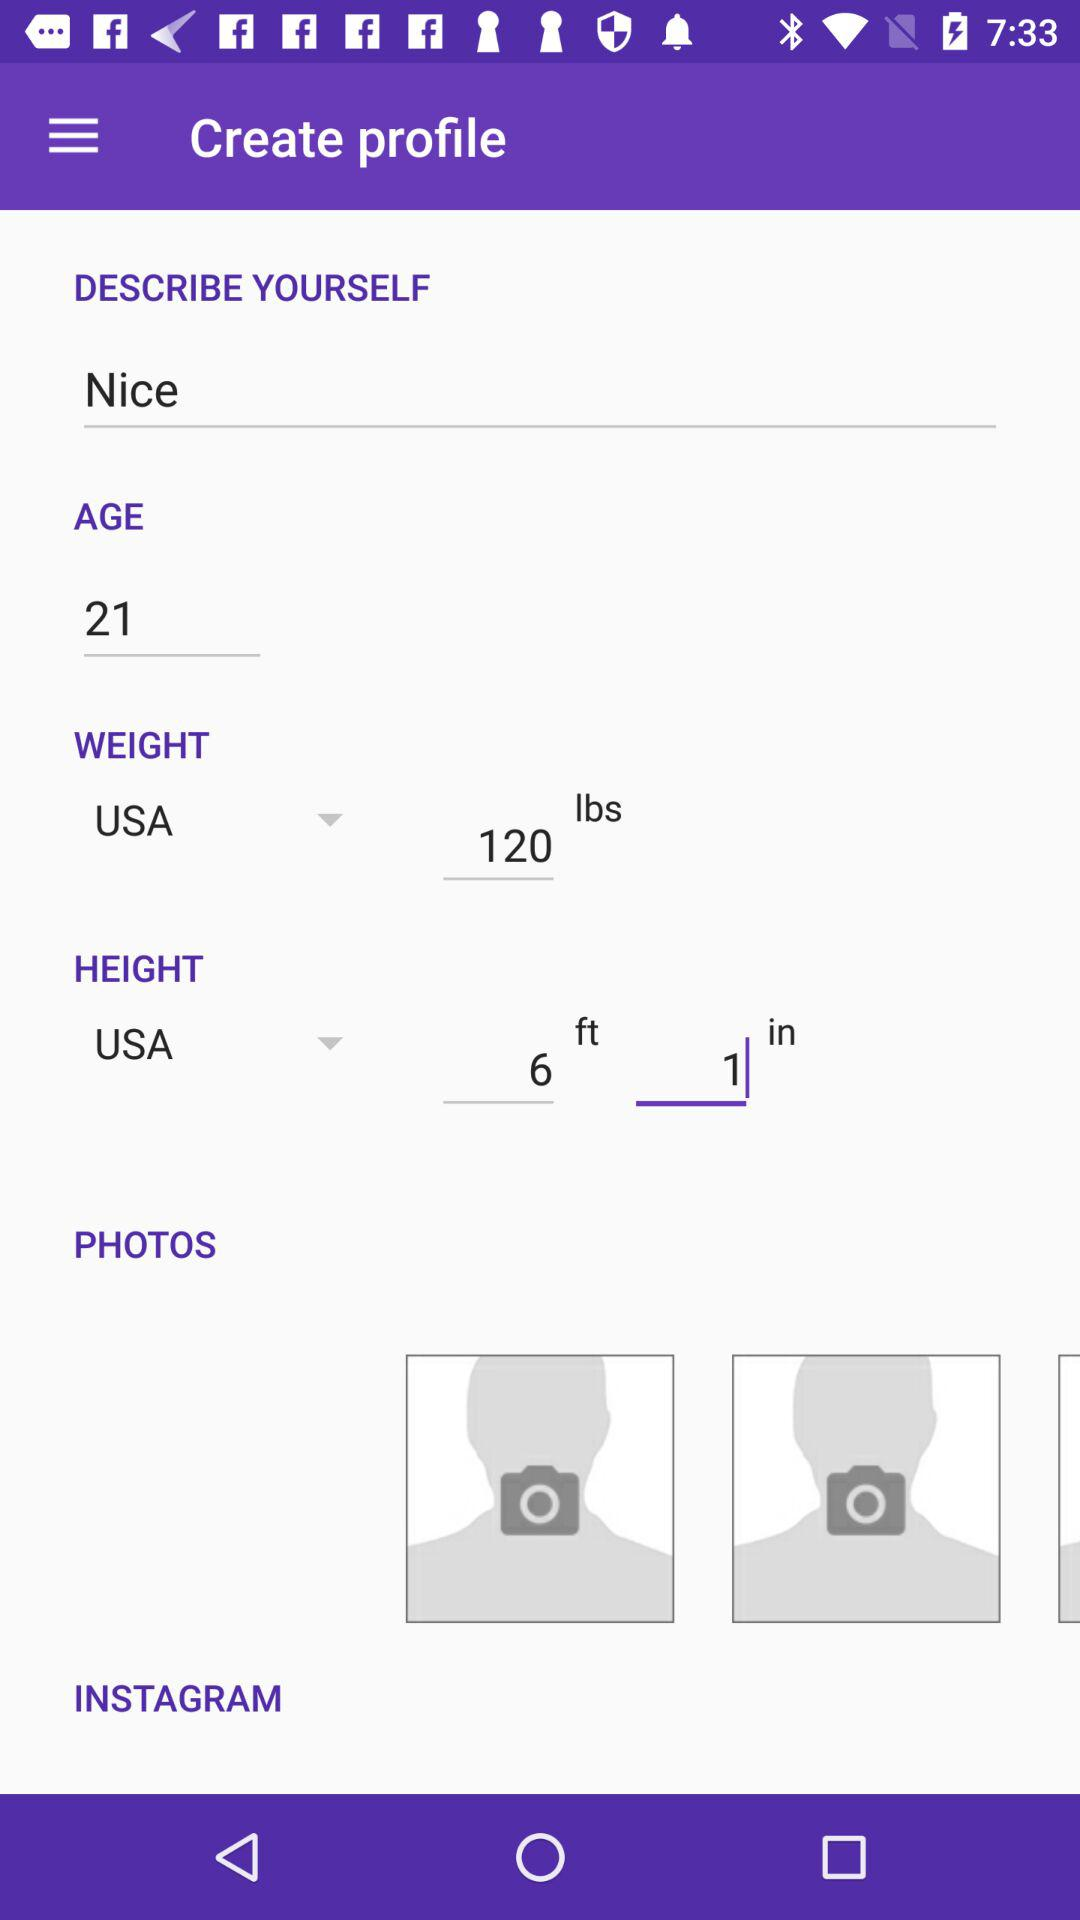What's the measuring unit of height? The measuring unit of height is feet and inches. 